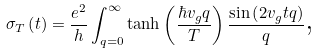Convert formula to latex. <formula><loc_0><loc_0><loc_500><loc_500>\sigma _ { T } \left ( t \right ) = \frac { e ^ { 2 } } { h } \int _ { q = 0 } ^ { \infty } \tanh \left ( \frac { \hbar { v } _ { g } q } { T } \right ) \frac { \sin \left ( 2 v _ { g } t q \right ) } { q } \text {,}</formula> 